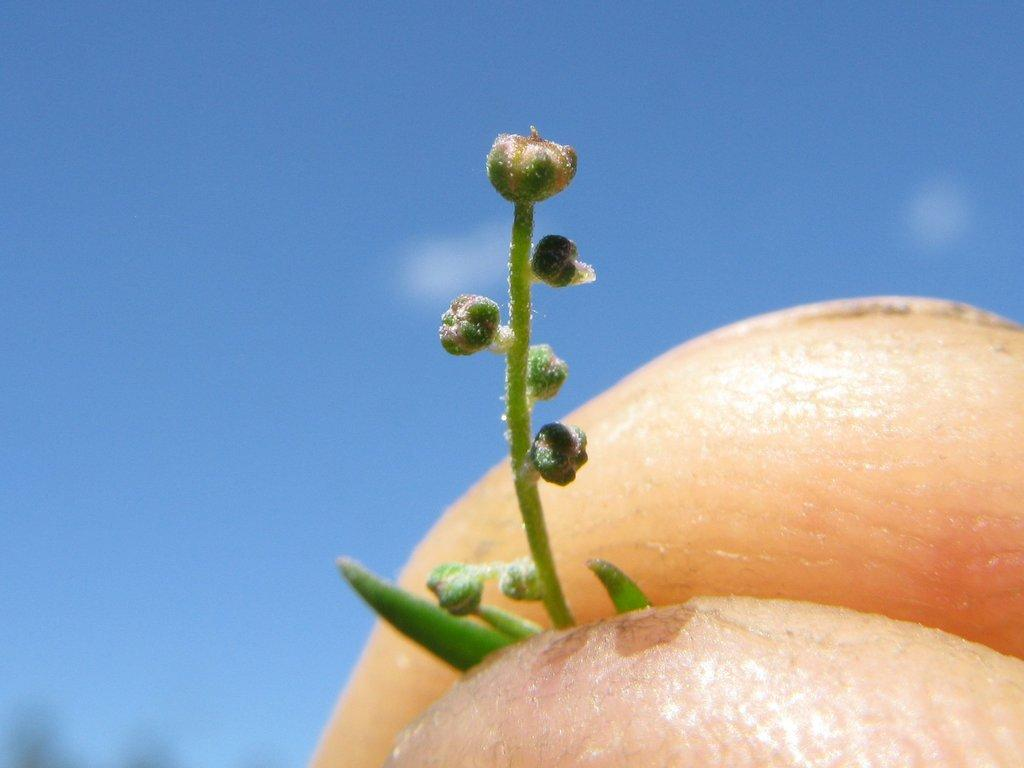What is the main subject of the image? There is a person in the image. What is the person holding in their hand? The person is holding a bud in their hand. What can be seen in the background of the image? The sky is visible in the image. What type of mine can be seen in the image? There is no mine present in the image. What type of weather can be observed in the image? The provided facts do not mention any specific weather conditions in the image. 